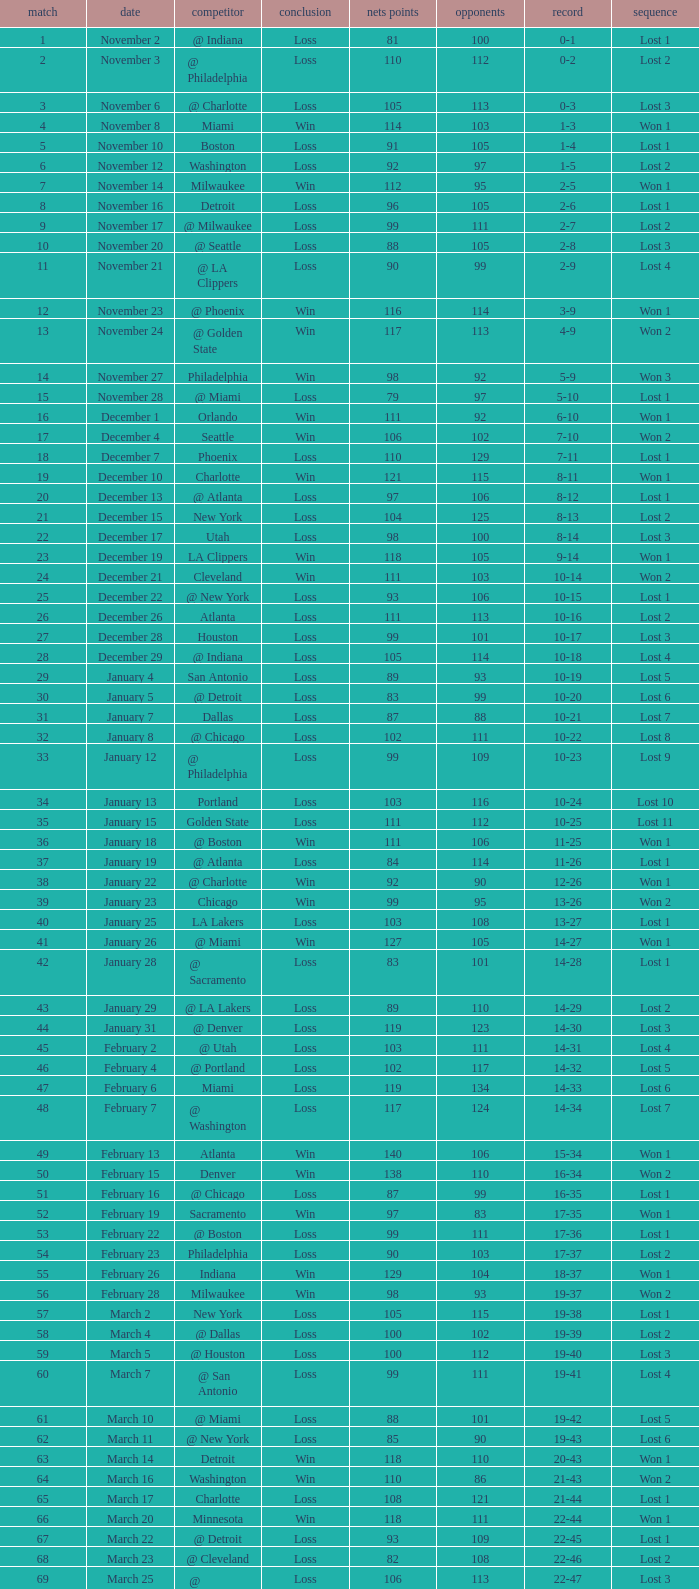What was the average point total for the nets in games before game 9 where the opponents scored less than 95? None. 